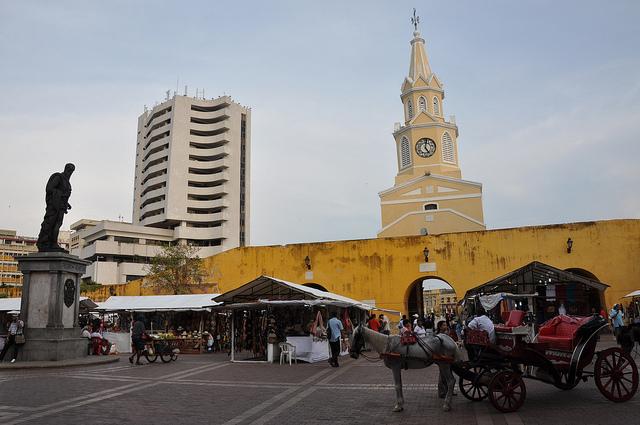What city is this?
Answer briefly. Brazil. Is the horse male?
Keep it brief. No. What color are the carriage wheels?
Answer briefly. Black. What is the building behind the tower constructed with?
Concise answer only. Concrete. What color is the clock tower on the right?
Concise answer only. Cream. What is the horse pulling?
Be succinct. Carriage. 